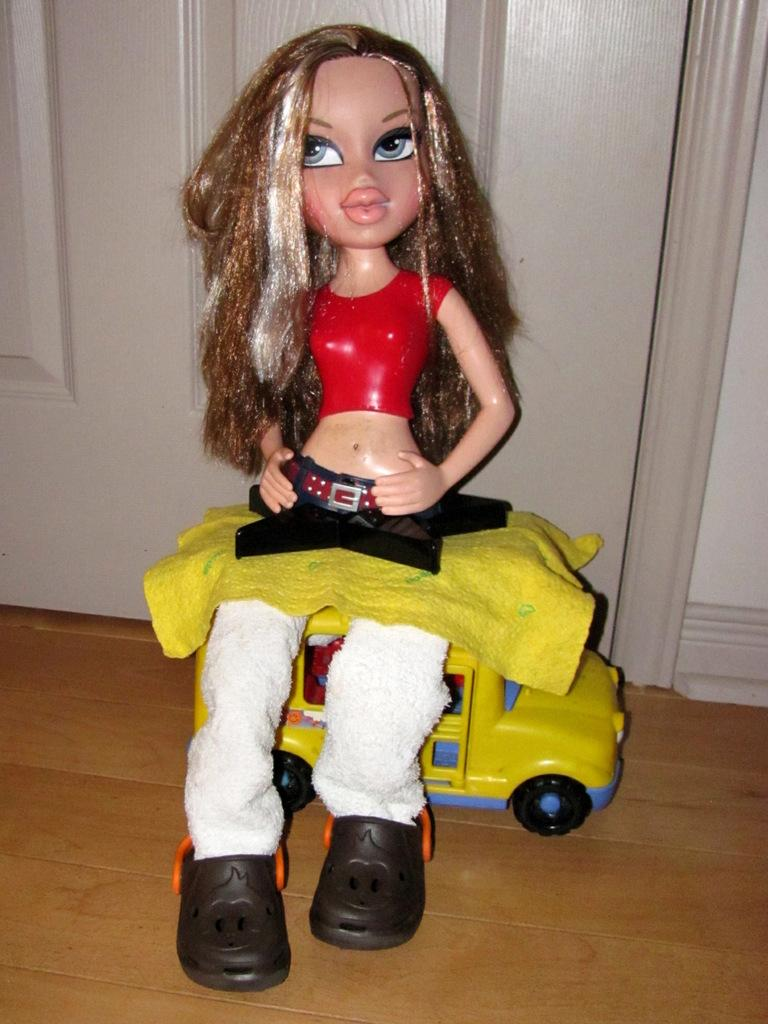What type of toy can be seen in the image? There is a toy car in the image. What other object is present in the image? There is a doll in the image. What can be seen in the background of the image? There is a door and a wall in the background of the image. What type of news can be seen on the wall in the image? There is no news present in the image; it only features a doll, a toy car, a door, and a wall. Can you see a rifle in the image? No, there is no rifle present in the image. 